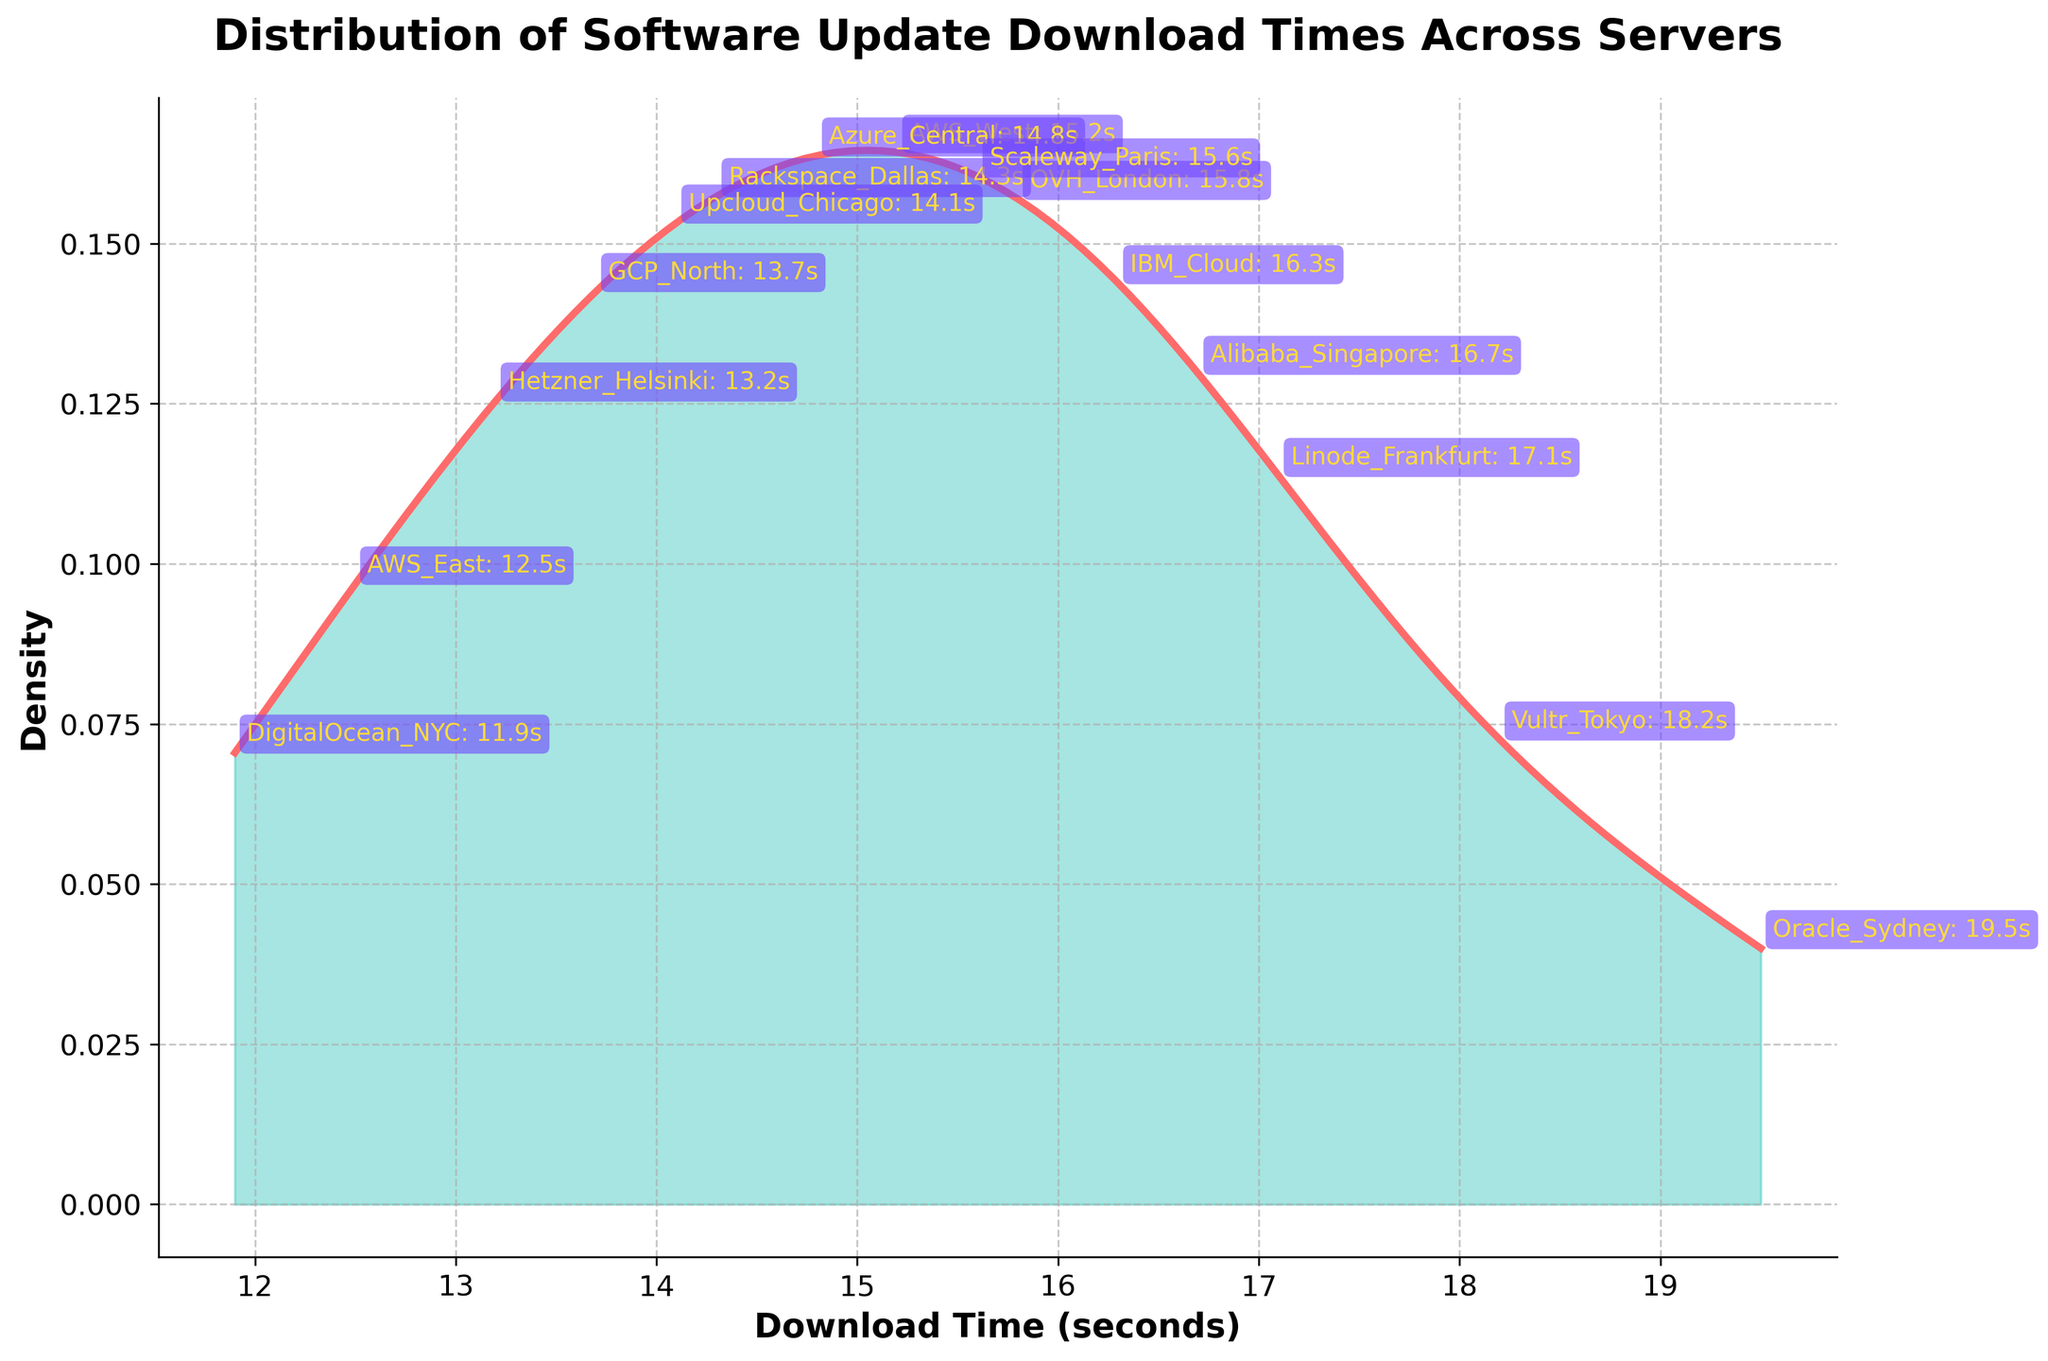What is the title of the plot? The title can be found at the top of the plot. It typically summarizes what the plot represents.
Answer: Distribution of Software Update Download Times Across Servers What are the units used on the X-axis? The label on the X-axis shows the units of measurement for the data in the plot.
Answer: Download Time (seconds) Which server has the longest download time? By observing the annotations that indicate the server names and their respective positions on the plot, you can identify the server with the highest download time.
Answer: Oracle_Sydney What is the approximate density value for Vultr_Tokyo's download time? Locate Vultr_Tokyo on the plot and note the position on the Y-axis, which represents the density.
Answer: ~0.048 How many servers have download times between 15 and 18 seconds? Count the annotations that fall between the 15 and 18-second marks on the X-axis.
Answer: 6 servers (AWS_West, Azure_Central, Rackspace_Dallas, OVH_London, Scaleway_Paris, Alibaba_Singapore) Which server has a lower download time, Hetzner_Helsinki or DigitalOcean_NYC? Compare the positions of Hetzner_Helsinki and DigitalOcean_NYC on the X-axis.
Answer: DigitalOcean_NYC What can you infer about the variability in download times across different servers? Consider the spread and shape of the density plot to interpret the variability or spread of the download times across different servers.
Answer: High variability How does the density at AWS_East's download time compare to that at IBM_Cloud's download time? Observe the height of the density curve at these two points on the X-axis to compare their densities.
Answer: AWS_East's density is higher than IBM_Cloud's density What does a density plot tell you about the distribution of the data? Understand the purpose of a density plot, which shows the probability density function of the continuous random variable. It indicates where values are more concentrated.
Answer: Shows the distribution's concentration and spread 